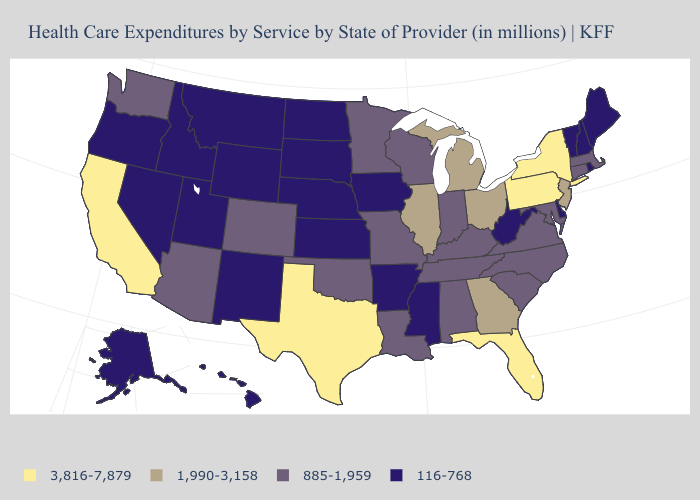What is the value of Connecticut?
Short answer required. 885-1,959. What is the lowest value in the South?
Quick response, please. 116-768. Name the states that have a value in the range 116-768?
Keep it brief. Alaska, Arkansas, Delaware, Hawaii, Idaho, Iowa, Kansas, Maine, Mississippi, Montana, Nebraska, Nevada, New Hampshire, New Mexico, North Dakota, Oregon, Rhode Island, South Dakota, Utah, Vermont, West Virginia, Wyoming. Among the states that border Washington , which have the highest value?
Be succinct. Idaho, Oregon. Does Ohio have a lower value than California?
Quick response, please. Yes. Which states have the highest value in the USA?
Quick response, please. California, Florida, New York, Pennsylvania, Texas. What is the value of Delaware?
Answer briefly. 116-768. What is the lowest value in the Northeast?
Short answer required. 116-768. Is the legend a continuous bar?
Write a very short answer. No. Name the states that have a value in the range 885-1,959?
Answer briefly. Alabama, Arizona, Colorado, Connecticut, Indiana, Kentucky, Louisiana, Maryland, Massachusetts, Minnesota, Missouri, North Carolina, Oklahoma, South Carolina, Tennessee, Virginia, Washington, Wisconsin. Name the states that have a value in the range 1,990-3,158?
Short answer required. Georgia, Illinois, Michigan, New Jersey, Ohio. What is the highest value in states that border Texas?
Be succinct. 885-1,959. Name the states that have a value in the range 3,816-7,879?
Give a very brief answer. California, Florida, New York, Pennsylvania, Texas. What is the value of Mississippi?
Answer briefly. 116-768. 